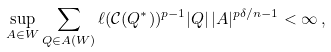<formula> <loc_0><loc_0><loc_500><loc_500>\sup _ { A \in W } \sum _ { Q \in A ( W ) } \ell ( \mathcal { C } ( Q ^ { * } ) ) ^ { p - 1 } | Q | \, | A | ^ { p \delta / n - 1 } < \infty \, ,</formula> 